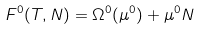<formula> <loc_0><loc_0><loc_500><loc_500>F ^ { 0 } ( T , N ) = \Omega ^ { 0 } ( \mu ^ { 0 } ) + \mu ^ { 0 } N</formula> 